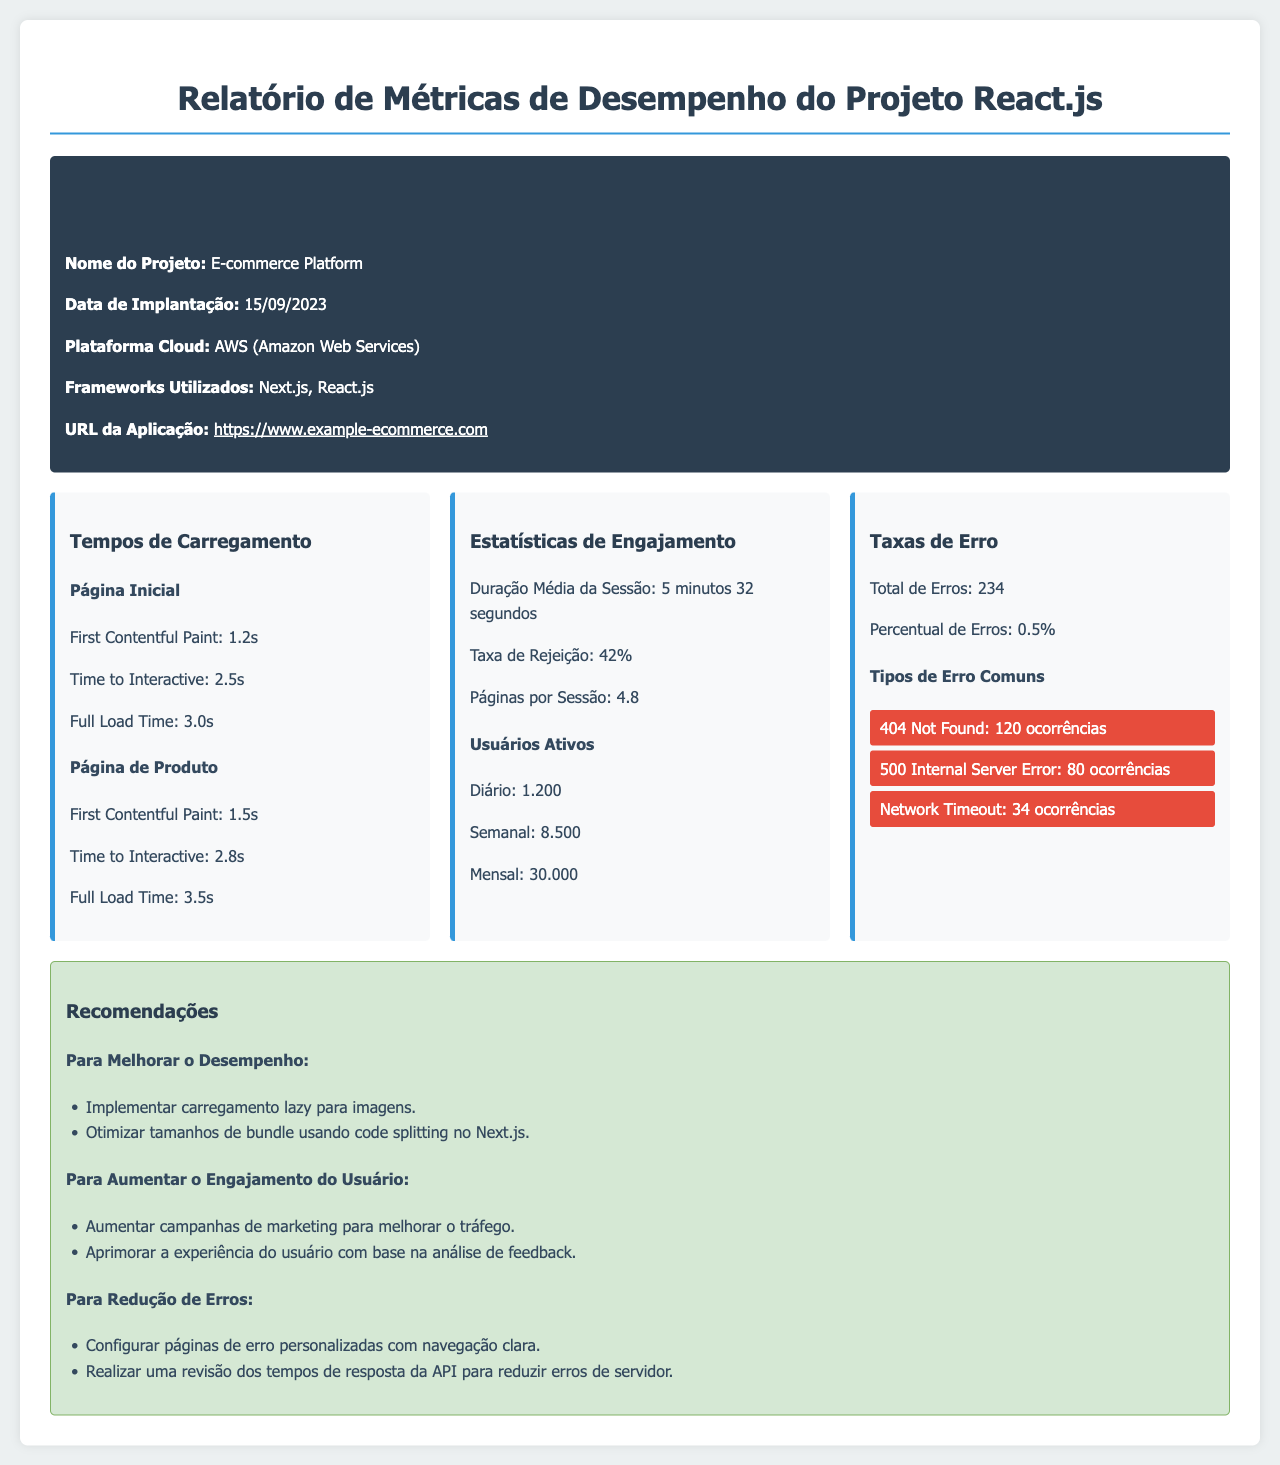Qual é o nome do projeto? O nome do projeto é mencionado na seção de detalhes do projeto.
Answer: E-commerce Platform Quando foi a data de implantação? A data de implantação é especificada na área de detalhes do projeto.
Answer: 15/09/2023 Qual é a taxa de rejeição? A taxa de rejeição é uma métrica de engajamento apresentada no relatório.
Answer: 42% Qual é o número total de erros? O total de erros é uma métrica apresentada na seção de taxas de erro.
Answer: 234 Qual é o tempo de carregamento total da página inicial? O tempo de carregamento total da página inicial é especificado nas métricas de desempenho.
Answer: 3.0s Qual é a duração média da sessão? A duração média da sessão é uma estatística de engajamento apresentada.
Answer: 5 minutos 32 segundos Quantas ocorrências de "404 Not Found" foram registradas? As ocorrências de erros são listadas na seção de taxas de erro.
Answer: 120 ocorrências Quais são as recomendações para aumentar o engajamento do usuário? As recomendações são apresentadas na seção de iniciativas para melhorar desempenho e engajamento.
Answer: Aumentar campanhas de marketing para melhorar o tráfego Quais frameworks foram utilizados? Os frameworks utilizados são listados na área de detalhes do projeto.
Answer: Next.js, React.js 